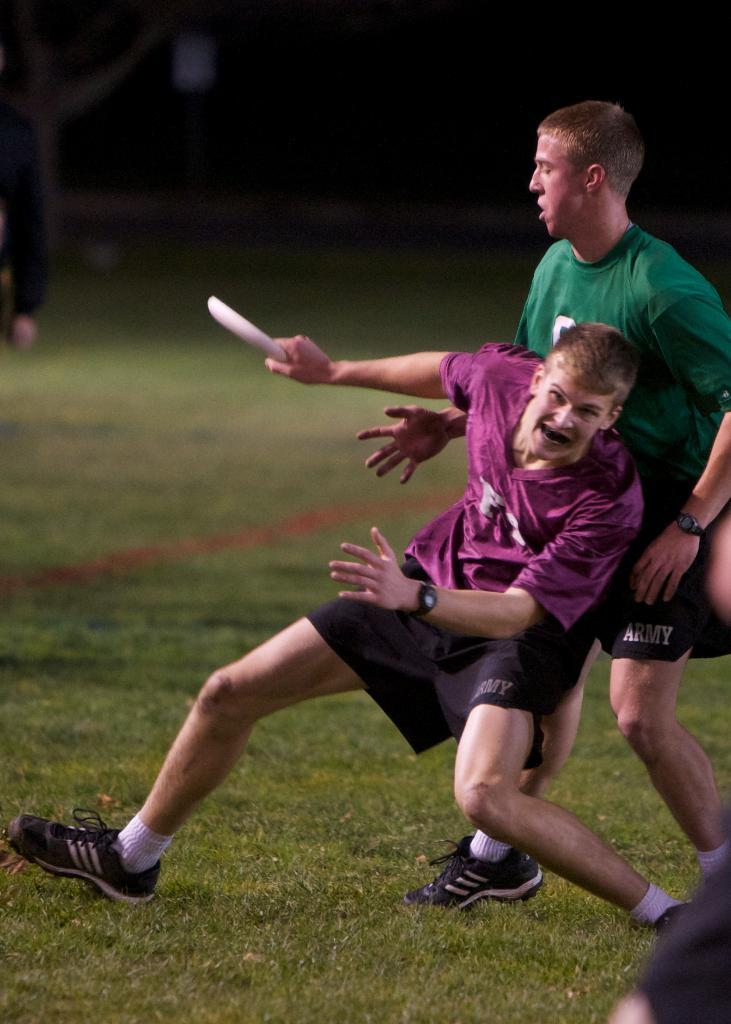How many people are in the image? There are two men in the image. What is one of the men doing in the image? One of the men is holding something. What type of surface is at the bottom of the image? There is grass at the bottom of the image. How would you describe the lighting in the image? The background of the image is dark. How many cats can be seen in the image? There are no cats present in the image. What type of can is visible in the image? There is no can present in the image. 